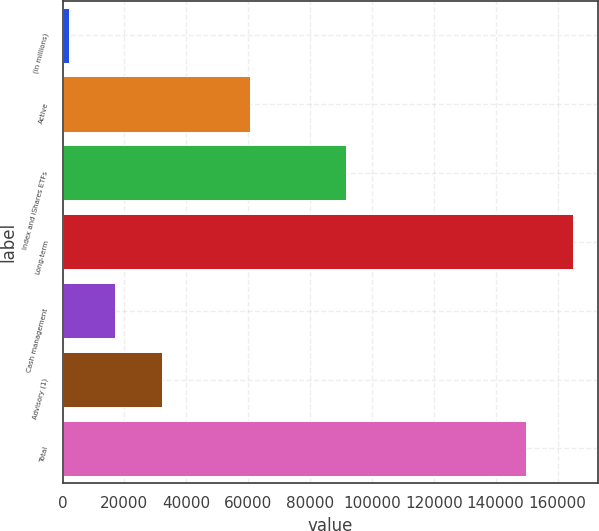Convert chart. <chart><loc_0><loc_0><loc_500><loc_500><bar_chart><fcel>(in millions)<fcel>Active<fcel>Index and iShares ETFs<fcel>Long-term<fcel>Cash management<fcel>Advisory (1)<fcel>Total<nl><fcel>2015<fcel>60510<fcel>91504<fcel>164895<fcel>17014.9<fcel>32014.8<fcel>149895<nl></chart> 